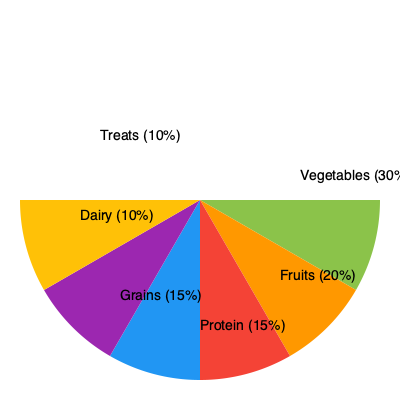Based on the pie chart showing the composition of a balanced meal, what percentage of the meal should consist of fruits and vegetables combined to promote a healthier diet while still allowing for treats? To answer this question, we need to follow these steps:

1. Identify the percentages for fruits and vegetables in the pie chart:
   - Vegetables: 30%
   - Fruits: 20%

2. Add the percentages of fruits and vegetables:
   $30\% + 20\% = 50\%$

3. Verify that the pie chart includes a small portion for treats:
   - Treats: 10%

4. Confirm that the total adds up to 100%:
   Vegetables (30%) + Fruits (20%) + Protein (15%) + Grains (15%) + Dairy (10%) + Treats (10%) = 100%

5. Conclude that the combination of fruits and vegetables (50%) provides a significant portion of the meal, promoting a healthier diet, while still allowing for a small portion of treats (10%) to satisfy sweet cravings.
Answer: 50% 